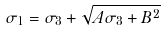<formula> <loc_0><loc_0><loc_500><loc_500>\sigma _ { 1 } = \sigma _ { 3 } + \sqrt { A \sigma _ { 3 } + B ^ { 2 } }</formula> 